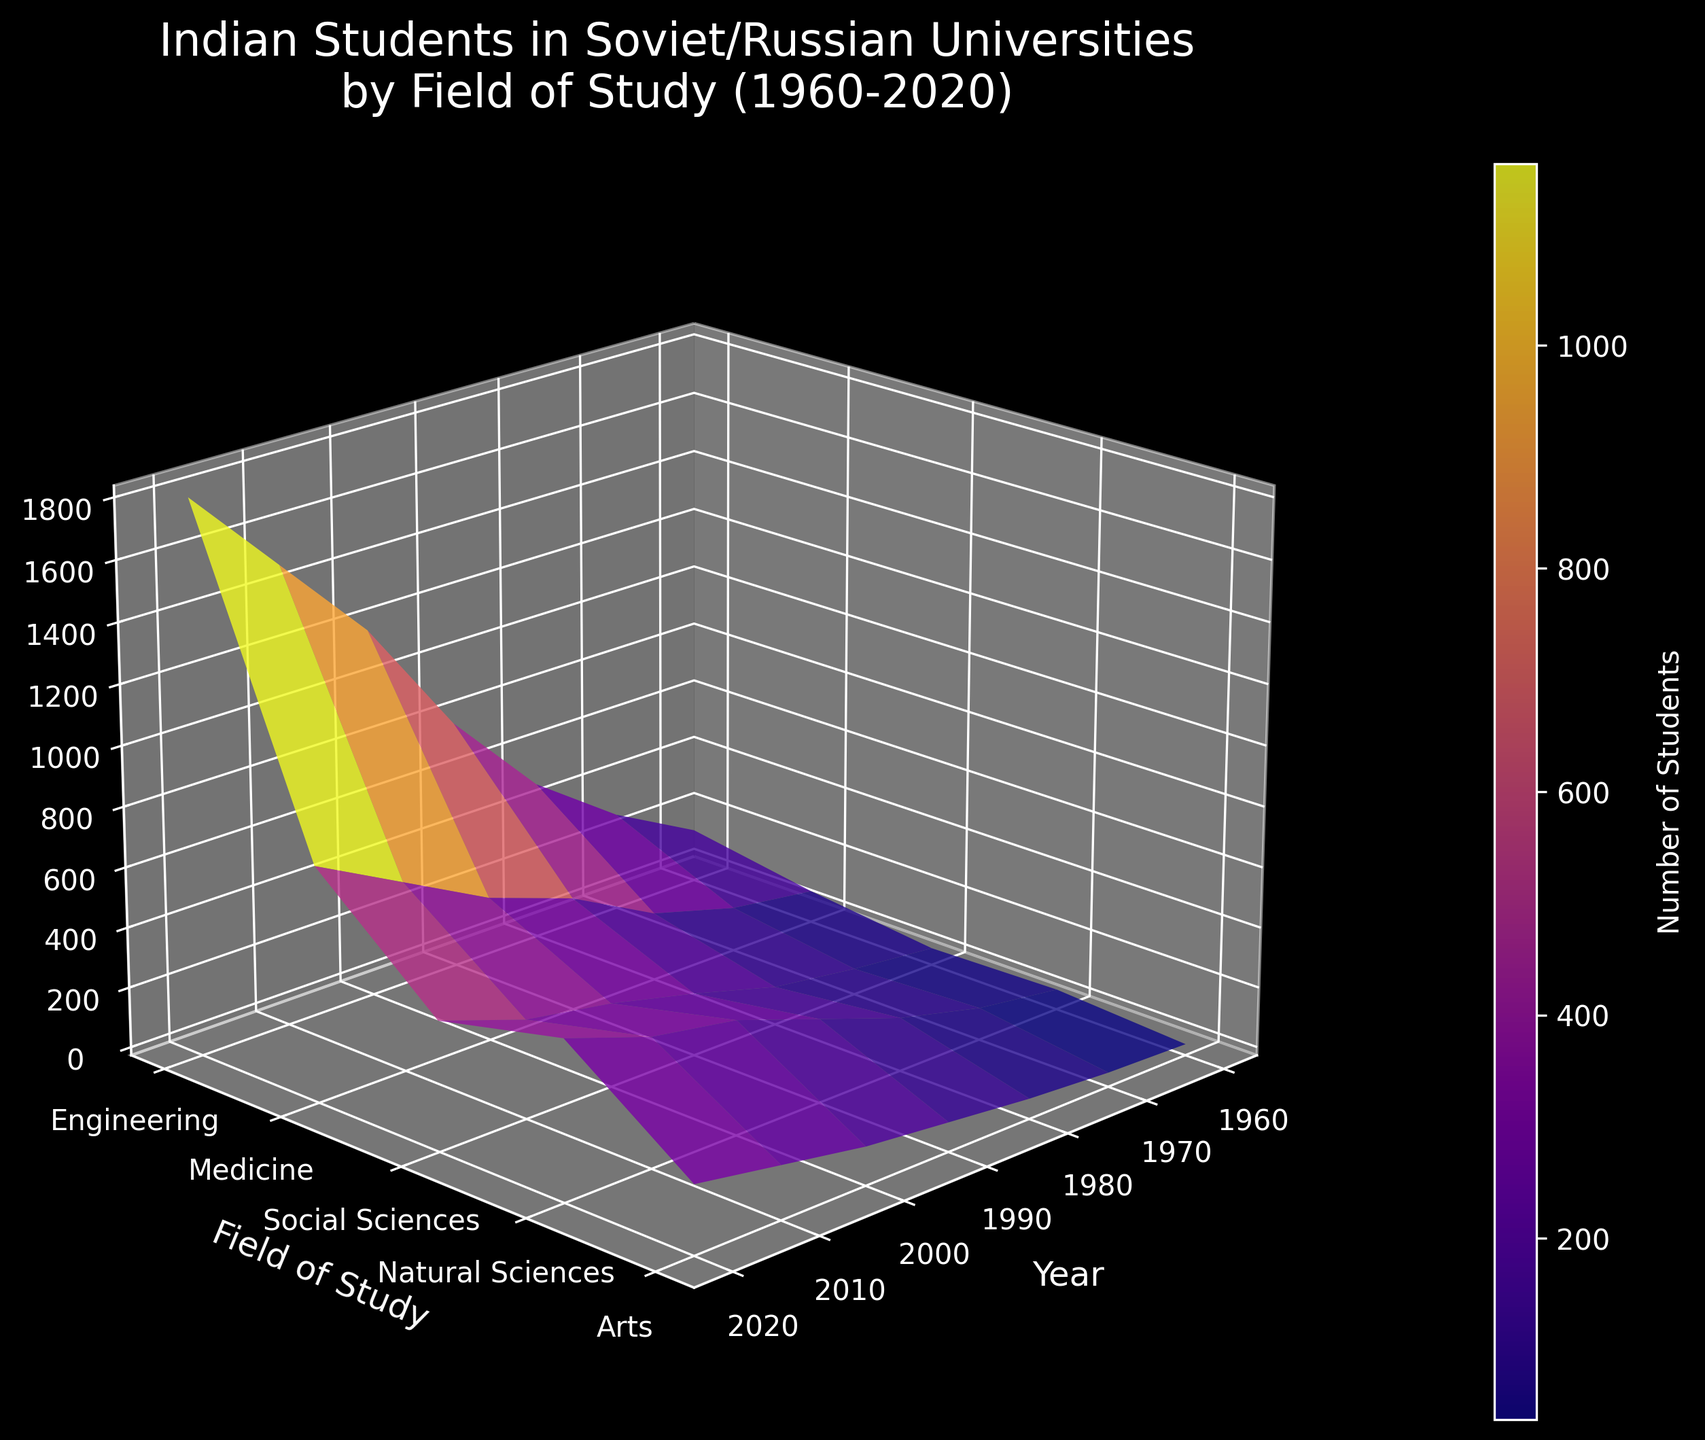What's the title of the plot? The title is located at the top of the 3D surface plot and summarizes the subject of the visualization, which shows the trends of Indian students in Soviet/Russian universities by fields of study over several decades.
Answer: Indian Students in Soviet/Russian Universities by Field of Study (1960-2020) Which field of study has the highest number of students in 2020? The highest point on the surface plot in 2020 along the year axis corresponds to the Y axis label "Field of Study" with the highest value along the Z axis (Number of Students).
Answer: Engineering What is the approximate number of students in Medicine in 1990? Locate the intersection of the "Medicine" field on the Y axis with the year 1990 on the X axis, then estimate the value on the Z axis (vertical) at that point.
Answer: Around 350 How did the number of students in Arts change from 1960 to 2020? Compare the Z axis values for "Arts" at the years 1960 and 2020 by examining their relative heights on the plot.
Answer: Increased from 10 to 200 Compare the trends in the number of students between Medicine and Natural Sciences from 1960 to 2020. Trace the Medicine trend and the Natural Sciences trend along the year axis, noting their values on the Z axis to determine their growth patterns over time.
Answer: Both show consistent growth, but Medicine has larger values throughout When did Engineering see the highest single-decade increase in the number of students? Identify the decade where the Z axis height for Engineering shows the largest increase between any two consecutive years.
Answer: 1990 to 2000 What is the range of the number of students in Social Sciences over the entire period? Determine the minimum and maximum values for Social Sciences on the Z axis across all years and then calculate the difference.
Answer: 30 to 400, range is 370 Which field had a more significant rate of increase in the number of students from 1980 to 2000, Engineering or Arts? Calculate the difference in Z axis values for both fields from 1980 to 2000, then compare the magnitude of these changes.
Answer: Engineering How many fields of study are represented in the plot? Count the number of unique labels along the Y axis, which denotes the different fields of study.
Answer: 5 What are the Y-axis labels for the fields of study? The Y-axis labels are the fields of study listed on the Y-axis of the 3D surface plot.
Answer: Engineering, Medicine, Social Sciences, Natural Sciences, Arts 